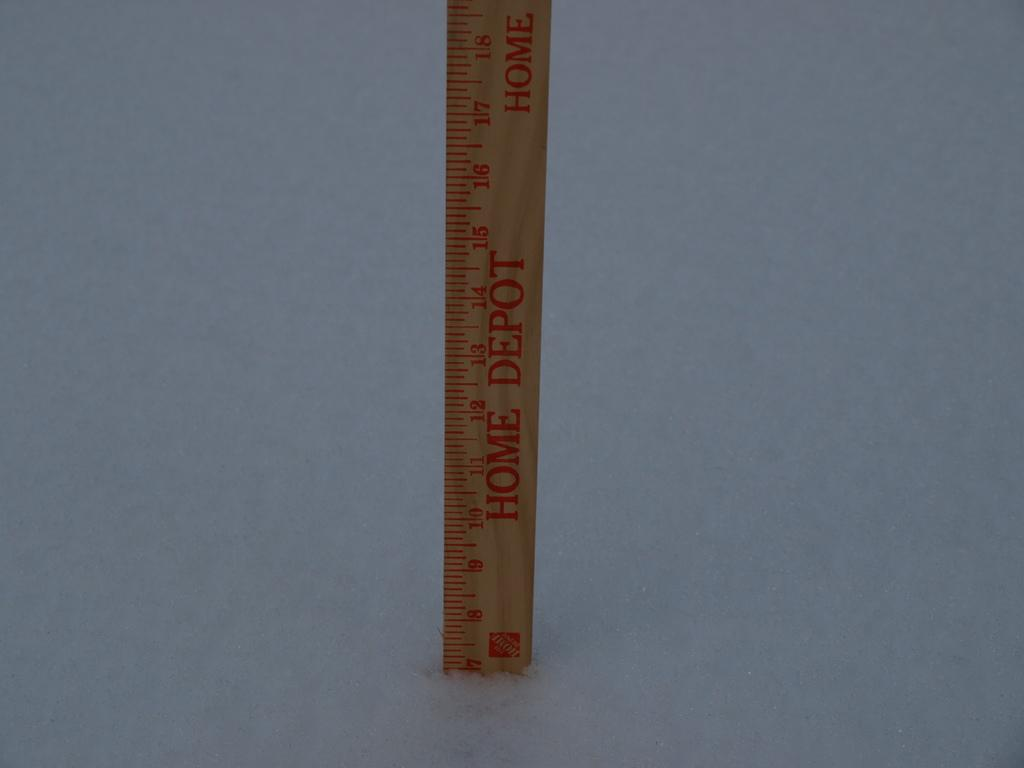<image>
Share a concise interpretation of the image provided. a ruler that is labeled 'home depot' in red 